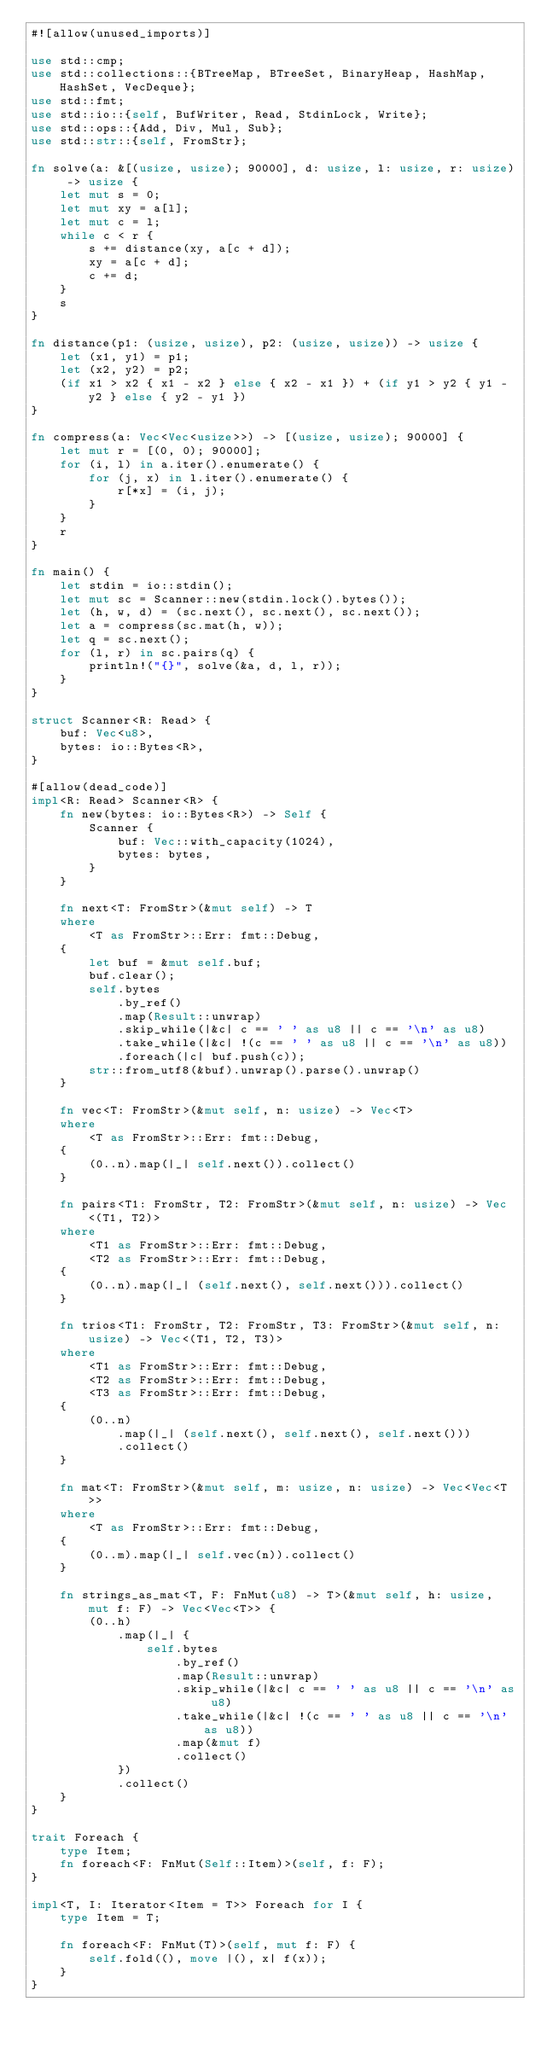Convert code to text. <code><loc_0><loc_0><loc_500><loc_500><_Rust_>#![allow(unused_imports)]

use std::cmp;
use std::collections::{BTreeMap, BTreeSet, BinaryHeap, HashMap, HashSet, VecDeque};
use std::fmt;
use std::io::{self, BufWriter, Read, StdinLock, Write};
use std::ops::{Add, Div, Mul, Sub};
use std::str::{self, FromStr};

fn solve(a: &[(usize, usize); 90000], d: usize, l: usize, r: usize) -> usize {
    let mut s = 0;
    let mut xy = a[l];
    let mut c = l;
    while c < r {
        s += distance(xy, a[c + d]);
        xy = a[c + d];
        c += d;
    }
    s
}

fn distance(p1: (usize, usize), p2: (usize, usize)) -> usize {
    let (x1, y1) = p1;
    let (x2, y2) = p2;
    (if x1 > x2 { x1 - x2 } else { x2 - x1 }) + (if y1 > y2 { y1 - y2 } else { y2 - y1 })
}

fn compress(a: Vec<Vec<usize>>) -> [(usize, usize); 90000] {
    let mut r = [(0, 0); 90000];
    for (i, l) in a.iter().enumerate() {
        for (j, x) in l.iter().enumerate() {
            r[*x] = (i, j);
        }
    }
    r
}

fn main() {
    let stdin = io::stdin();
    let mut sc = Scanner::new(stdin.lock().bytes());
    let (h, w, d) = (sc.next(), sc.next(), sc.next());
    let a = compress(sc.mat(h, w));
    let q = sc.next();
    for (l, r) in sc.pairs(q) {
        println!("{}", solve(&a, d, l, r));
    }
}

struct Scanner<R: Read> {
    buf: Vec<u8>,
    bytes: io::Bytes<R>,
}

#[allow(dead_code)]
impl<R: Read> Scanner<R> {
    fn new(bytes: io::Bytes<R>) -> Self {
        Scanner {
            buf: Vec::with_capacity(1024),
            bytes: bytes,
        }
    }

    fn next<T: FromStr>(&mut self) -> T
    where
        <T as FromStr>::Err: fmt::Debug,
    {
        let buf = &mut self.buf;
        buf.clear();
        self.bytes
            .by_ref()
            .map(Result::unwrap)
            .skip_while(|&c| c == ' ' as u8 || c == '\n' as u8)
            .take_while(|&c| !(c == ' ' as u8 || c == '\n' as u8))
            .foreach(|c| buf.push(c));
        str::from_utf8(&buf).unwrap().parse().unwrap()
    }

    fn vec<T: FromStr>(&mut self, n: usize) -> Vec<T>
    where
        <T as FromStr>::Err: fmt::Debug,
    {
        (0..n).map(|_| self.next()).collect()
    }

    fn pairs<T1: FromStr, T2: FromStr>(&mut self, n: usize) -> Vec<(T1, T2)>
    where
        <T1 as FromStr>::Err: fmt::Debug,
        <T2 as FromStr>::Err: fmt::Debug,
    {
        (0..n).map(|_| (self.next(), self.next())).collect()
    }

    fn trios<T1: FromStr, T2: FromStr, T3: FromStr>(&mut self, n: usize) -> Vec<(T1, T2, T3)>
    where
        <T1 as FromStr>::Err: fmt::Debug,
        <T2 as FromStr>::Err: fmt::Debug,
        <T3 as FromStr>::Err: fmt::Debug,
    {
        (0..n)
            .map(|_| (self.next(), self.next(), self.next()))
            .collect()
    }

    fn mat<T: FromStr>(&mut self, m: usize, n: usize) -> Vec<Vec<T>>
    where
        <T as FromStr>::Err: fmt::Debug,
    {
        (0..m).map(|_| self.vec(n)).collect()
    }

    fn strings_as_mat<T, F: FnMut(u8) -> T>(&mut self, h: usize, mut f: F) -> Vec<Vec<T>> {
        (0..h)
            .map(|_| {
                self.bytes
                    .by_ref()
                    .map(Result::unwrap)
                    .skip_while(|&c| c == ' ' as u8 || c == '\n' as u8)
                    .take_while(|&c| !(c == ' ' as u8 || c == '\n' as u8))
                    .map(&mut f)
                    .collect()
            })
            .collect()
    }
}

trait Foreach {
    type Item;
    fn foreach<F: FnMut(Self::Item)>(self, f: F);
}

impl<T, I: Iterator<Item = T>> Foreach for I {
    type Item = T;

    fn foreach<F: FnMut(T)>(self, mut f: F) {
        self.fold((), move |(), x| f(x));
    }
}
</code> 